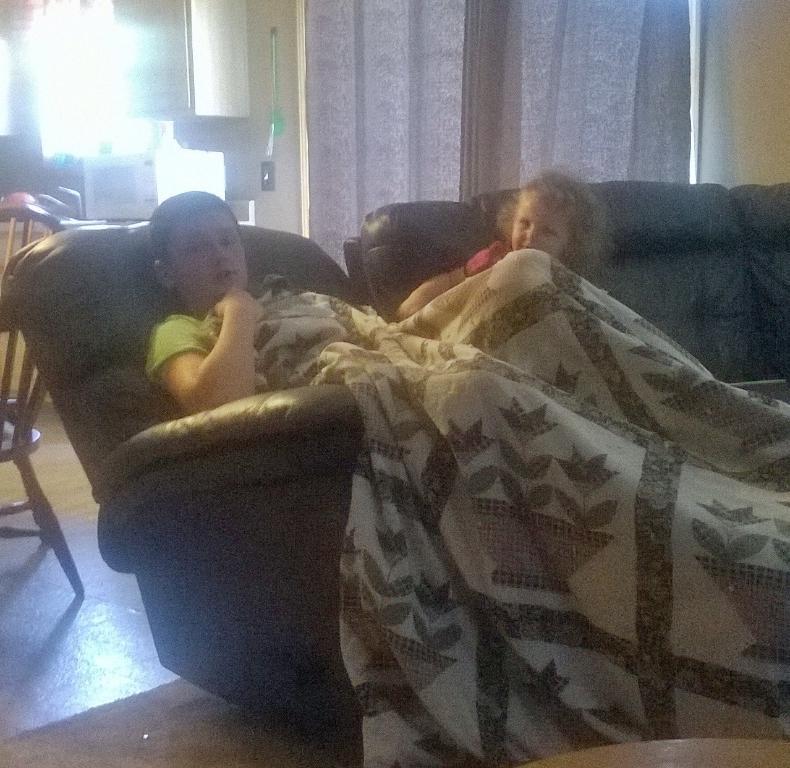Could you give a brief overview of what you see in this image? in the picture,we can see a room in which two persons are sitting on the chair,on one person there was blanket ,here we can also see the curtain to the wall and here we can also see chair. 